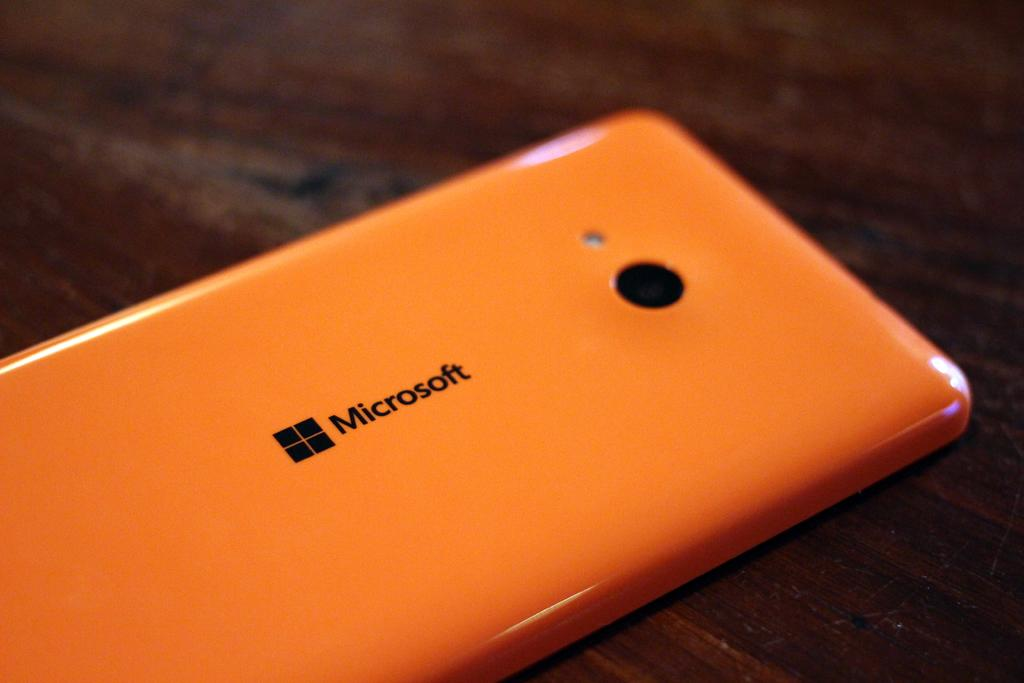<image>
Render a clear and concise summary of the photo. An orange Microsoft phone that is upside down and placed and a wooden table. 